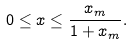<formula> <loc_0><loc_0><loc_500><loc_500>0 \leq x \leq { \frac { x _ { m } } { 1 + x _ { m } } } .</formula> 